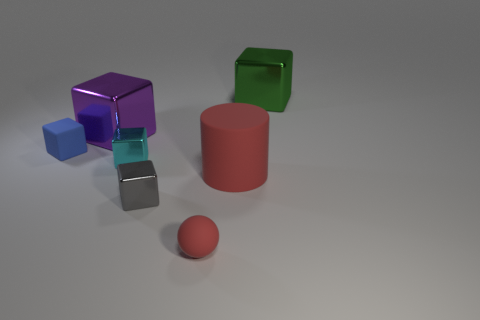Subtract all tiny gray cubes. How many cubes are left? 4 Subtract all purple blocks. How many blocks are left? 4 Subtract all yellow cubes. Subtract all purple balls. How many cubes are left? 5 Add 1 big matte cylinders. How many objects exist? 8 Subtract all cubes. How many objects are left? 2 Add 1 big brown metal things. How many big brown metal things exist? 1 Subtract 0 brown blocks. How many objects are left? 7 Subtract all small cubes. Subtract all big red metallic cylinders. How many objects are left? 4 Add 1 large green objects. How many large green objects are left? 2 